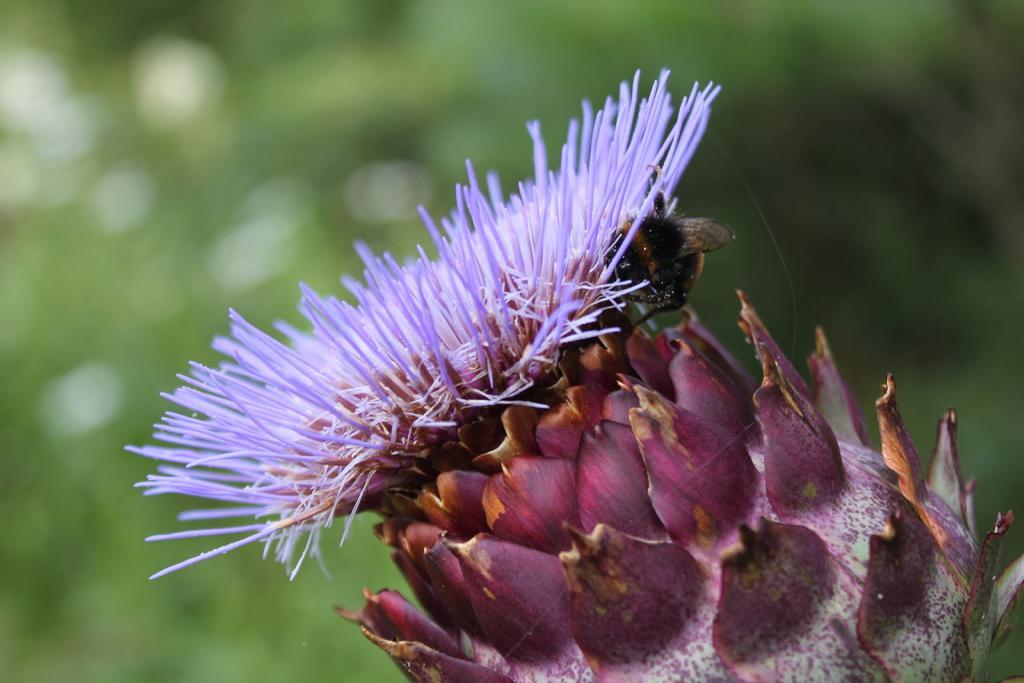How would you summarize this image in a sentence or two? In this image I can see a flower which is in violet color and its leaves are in pink color. On this flower I can see a bee. 